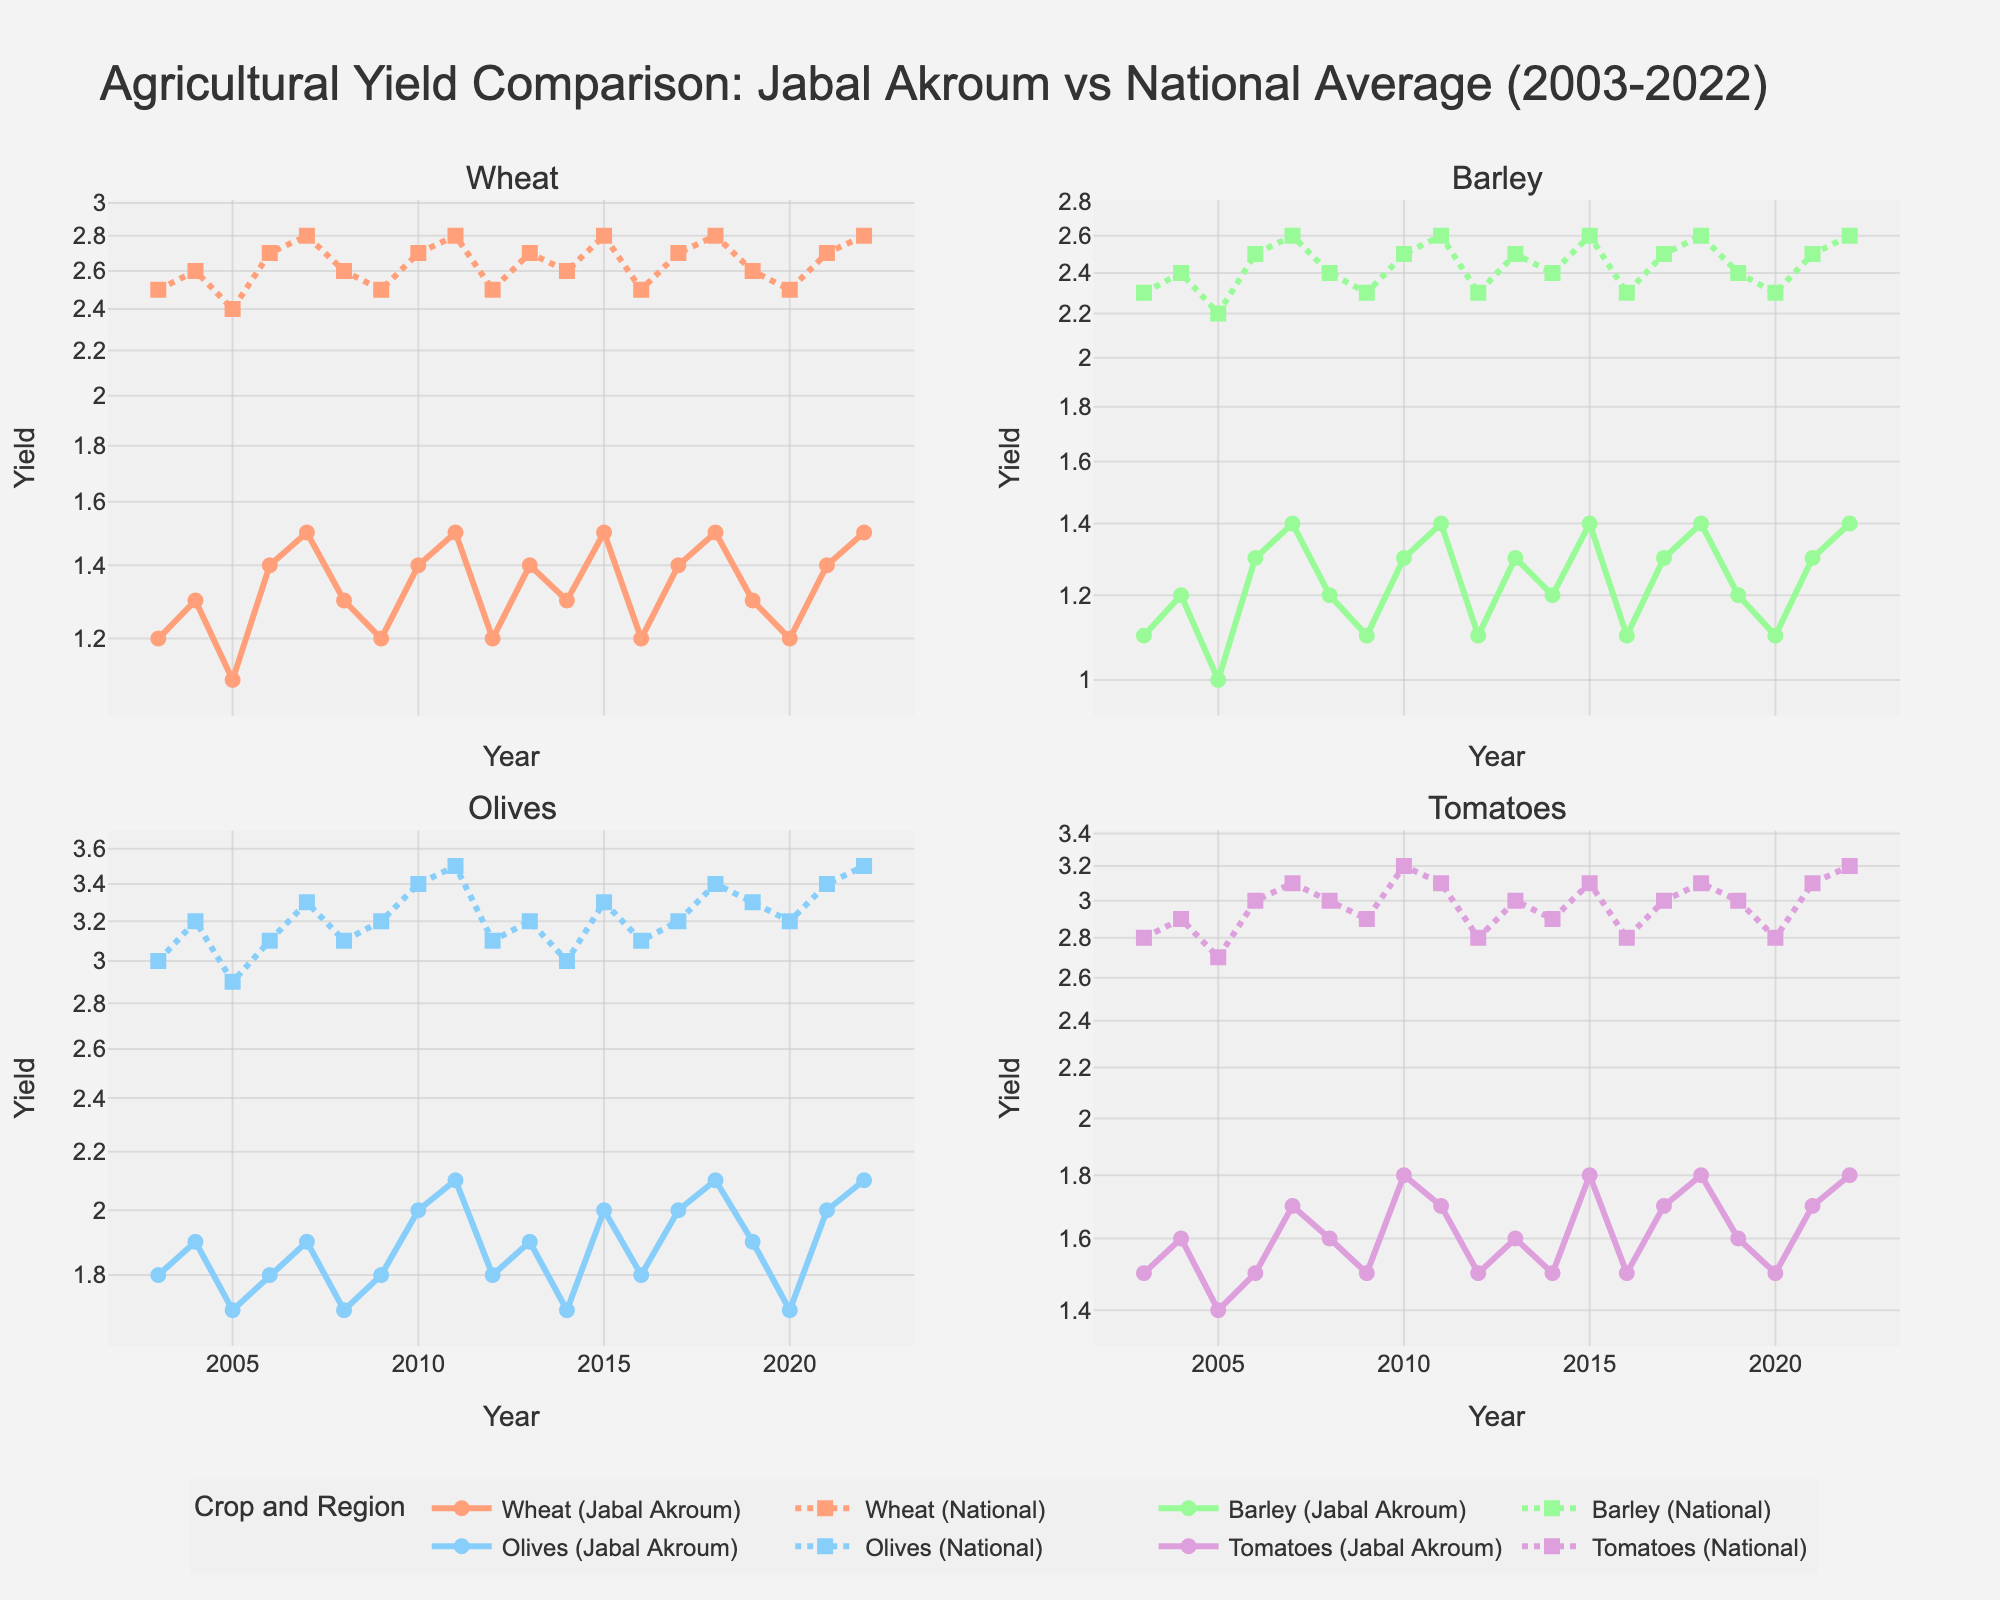What's the title of the plot? The title is directly above the figure in a large font and clearly states the main subject of the visualization.
Answer: Agricultural Yield Comparison: Jabal Akroum vs National Average (2003-2022) How many subplots are there in this figure? The figure is divided into a grid format with multiple smaller plots. By counting the individual plots, we see there are four subplots.
Answer: 4 What crops are analyzed in the subplots? The titles of the subplots indicate the specific crops being analyzed. We can see from the subplot titles that the crops analyzed are Wheat, Barley, Olives, and Tomatoes.
Answer: Wheat, Barley, Olives, and Tomatoes Which crop had the closest yield between Jabal Akroum and the national average in 2022? By examining the yield values for each crop in both Jabal Akroum and the national average in 2022, we can compare the final data points. Olives show the smallest difference between the two regions.
Answer: Olives How does the yield of Wheat in Jabal Akroum compare to the national average in 2010? Looking at the 2010 data points in the Wheat subplot, we compare the values of Jabal Akroum and the national average. Wheat yield in Jabal Akroum is 1.4, while the national average is 2.7, visually confirming that Jabal Akroum's yield is significantly lower.
Answer: Lower What is the average yield of Barley in Jabal Akroum from 2003 to 2022? First, we sum up all the Barley yields in Jabal Akroum for the specified years (1.1 + 1.2 + 1.0 + 1.3 + 1.4 + 1.2 + 1.1 + 1.3 + 1.4 + 1.1 + 1.3 + 1.2 + 1.4 + 1.1 + 1.3 + 1.4 + 1.2 + 1.1 + 1.3 + 1.4), which equals 25.2. Dividing by the 20 years gives us an average yield of 1.26.
Answer: 1.26 Which crop in Jabal Akroum showed the highest variation in yields over the years? By examining the variance in the y-values for each crop subplot and noting the spread of data points, Olives in Jabal Akroum show the highest variation in yield.
Answer: Olives Between 2010 and 2015, did Tomato yields in Jabal Akroum increase, decrease, or remain the same? Observing the Tomato subplot from 2010 to 2015, we track the data points for those years (1.8 in 2010 to 1.8 in 2015), noting that the yields remained consistent.
Answer: Remain the same Are there any years where the yield for any crop in Jabal Akroum is higher than the national average? By comparing the yields for all crops and years, we find that there are no instances where Jabal Akroum's yield surpasses the national average for any crop.
Answer: No 